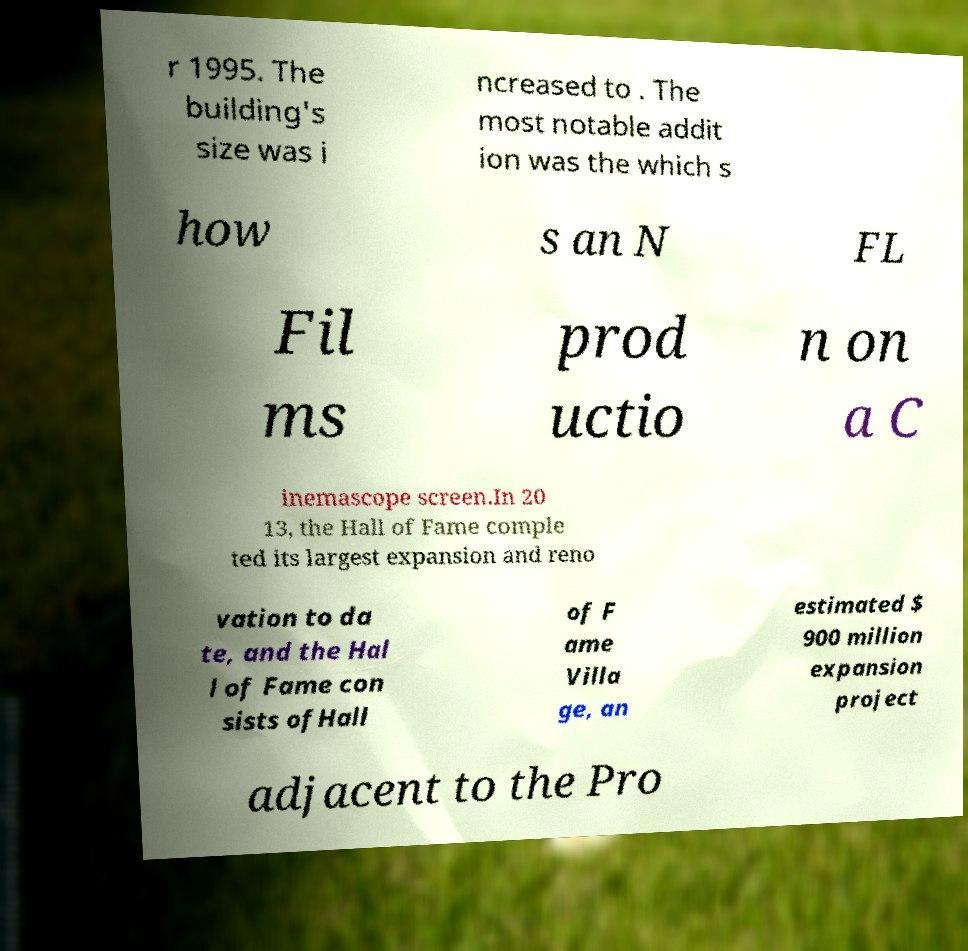I need the written content from this picture converted into text. Can you do that? r 1995. The building's size was i ncreased to . The most notable addit ion was the which s how s an N FL Fil ms prod uctio n on a C inemascope screen.In 20 13, the Hall of Fame comple ted its largest expansion and reno vation to da te, and the Hal l of Fame con sists ofHall of F ame Villa ge, an estimated $ 900 million expansion project adjacent to the Pro 